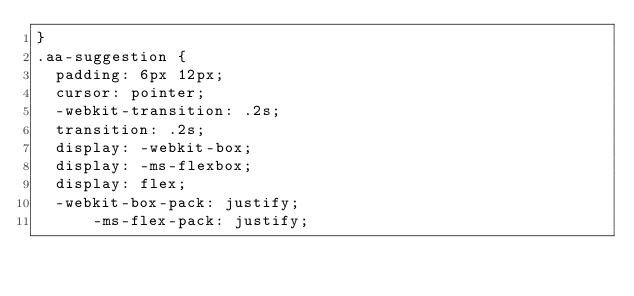Convert code to text. <code><loc_0><loc_0><loc_500><loc_500><_CSS_>}
.aa-suggestion {
  padding: 6px 12px;
  cursor: pointer;
  -webkit-transition: .2s;
  transition: .2s;
  display: -webkit-box;
  display: -ms-flexbox;
  display: flex;
  -webkit-box-pack: justify;
      -ms-flex-pack: justify;</code> 